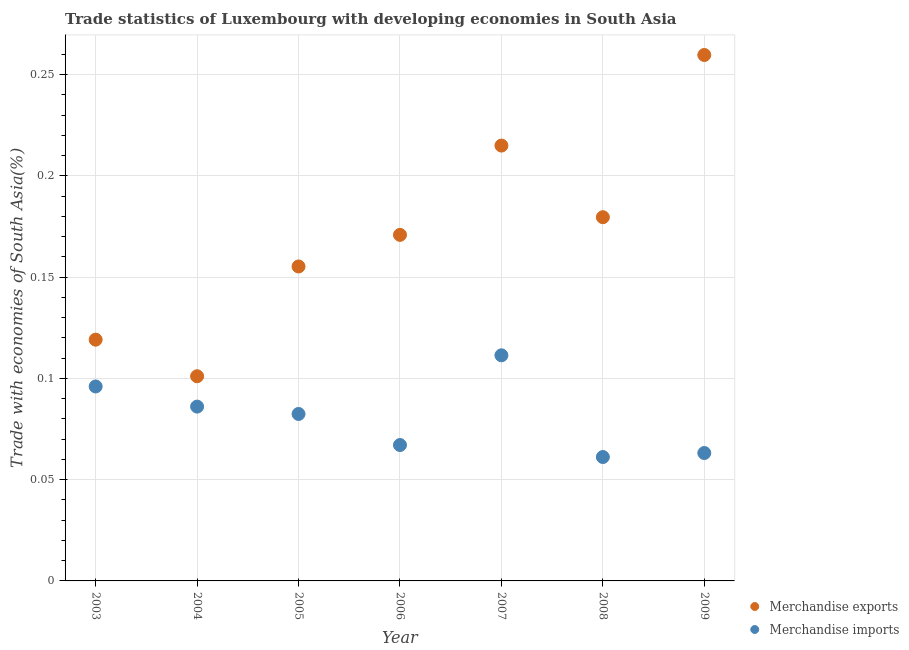How many different coloured dotlines are there?
Offer a terse response. 2. Is the number of dotlines equal to the number of legend labels?
Your response must be concise. Yes. What is the merchandise exports in 2007?
Ensure brevity in your answer.  0.21. Across all years, what is the maximum merchandise exports?
Ensure brevity in your answer.  0.26. Across all years, what is the minimum merchandise exports?
Your answer should be compact. 0.1. In which year was the merchandise exports minimum?
Keep it short and to the point. 2004. What is the total merchandise imports in the graph?
Your answer should be very brief. 0.57. What is the difference between the merchandise imports in 2007 and that in 2008?
Give a very brief answer. 0.05. What is the difference between the merchandise exports in 2003 and the merchandise imports in 2008?
Provide a succinct answer. 0.06. What is the average merchandise imports per year?
Your answer should be compact. 0.08. In the year 2004, what is the difference between the merchandise imports and merchandise exports?
Provide a short and direct response. -0.01. In how many years, is the merchandise exports greater than 0.22 %?
Your answer should be very brief. 1. What is the ratio of the merchandise imports in 2005 to that in 2009?
Offer a very short reply. 1.31. Is the merchandise exports in 2004 less than that in 2005?
Offer a very short reply. Yes. Is the difference between the merchandise exports in 2005 and 2006 greater than the difference between the merchandise imports in 2005 and 2006?
Give a very brief answer. No. What is the difference between the highest and the second highest merchandise imports?
Give a very brief answer. 0.02. What is the difference between the highest and the lowest merchandise imports?
Make the answer very short. 0.05. Is the sum of the merchandise exports in 2003 and 2006 greater than the maximum merchandise imports across all years?
Provide a short and direct response. Yes. How many years are there in the graph?
Offer a very short reply. 7. Are the values on the major ticks of Y-axis written in scientific E-notation?
Offer a terse response. No. Where does the legend appear in the graph?
Ensure brevity in your answer.  Bottom right. How are the legend labels stacked?
Your answer should be compact. Vertical. What is the title of the graph?
Make the answer very short. Trade statistics of Luxembourg with developing economies in South Asia. Does "Female" appear as one of the legend labels in the graph?
Offer a terse response. No. What is the label or title of the X-axis?
Provide a succinct answer. Year. What is the label or title of the Y-axis?
Ensure brevity in your answer.  Trade with economies of South Asia(%). What is the Trade with economies of South Asia(%) in Merchandise exports in 2003?
Offer a terse response. 0.12. What is the Trade with economies of South Asia(%) in Merchandise imports in 2003?
Your answer should be compact. 0.1. What is the Trade with economies of South Asia(%) in Merchandise exports in 2004?
Keep it short and to the point. 0.1. What is the Trade with economies of South Asia(%) of Merchandise imports in 2004?
Your answer should be compact. 0.09. What is the Trade with economies of South Asia(%) in Merchandise exports in 2005?
Offer a very short reply. 0.16. What is the Trade with economies of South Asia(%) in Merchandise imports in 2005?
Ensure brevity in your answer.  0.08. What is the Trade with economies of South Asia(%) of Merchandise exports in 2006?
Your answer should be very brief. 0.17. What is the Trade with economies of South Asia(%) of Merchandise imports in 2006?
Offer a very short reply. 0.07. What is the Trade with economies of South Asia(%) of Merchandise exports in 2007?
Provide a short and direct response. 0.21. What is the Trade with economies of South Asia(%) of Merchandise imports in 2007?
Provide a short and direct response. 0.11. What is the Trade with economies of South Asia(%) in Merchandise exports in 2008?
Your answer should be very brief. 0.18. What is the Trade with economies of South Asia(%) in Merchandise imports in 2008?
Provide a succinct answer. 0.06. What is the Trade with economies of South Asia(%) of Merchandise exports in 2009?
Ensure brevity in your answer.  0.26. What is the Trade with economies of South Asia(%) in Merchandise imports in 2009?
Ensure brevity in your answer.  0.06. Across all years, what is the maximum Trade with economies of South Asia(%) of Merchandise exports?
Give a very brief answer. 0.26. Across all years, what is the maximum Trade with economies of South Asia(%) of Merchandise imports?
Your answer should be compact. 0.11. Across all years, what is the minimum Trade with economies of South Asia(%) in Merchandise exports?
Offer a very short reply. 0.1. Across all years, what is the minimum Trade with economies of South Asia(%) in Merchandise imports?
Your response must be concise. 0.06. What is the total Trade with economies of South Asia(%) in Merchandise exports in the graph?
Your answer should be very brief. 1.2. What is the total Trade with economies of South Asia(%) of Merchandise imports in the graph?
Make the answer very short. 0.57. What is the difference between the Trade with economies of South Asia(%) in Merchandise exports in 2003 and that in 2004?
Your answer should be compact. 0.02. What is the difference between the Trade with economies of South Asia(%) of Merchandise imports in 2003 and that in 2004?
Your response must be concise. 0.01. What is the difference between the Trade with economies of South Asia(%) of Merchandise exports in 2003 and that in 2005?
Offer a terse response. -0.04. What is the difference between the Trade with economies of South Asia(%) in Merchandise imports in 2003 and that in 2005?
Offer a very short reply. 0.01. What is the difference between the Trade with economies of South Asia(%) in Merchandise exports in 2003 and that in 2006?
Your answer should be compact. -0.05. What is the difference between the Trade with economies of South Asia(%) of Merchandise imports in 2003 and that in 2006?
Your answer should be very brief. 0.03. What is the difference between the Trade with economies of South Asia(%) in Merchandise exports in 2003 and that in 2007?
Keep it short and to the point. -0.1. What is the difference between the Trade with economies of South Asia(%) of Merchandise imports in 2003 and that in 2007?
Provide a succinct answer. -0.02. What is the difference between the Trade with economies of South Asia(%) of Merchandise exports in 2003 and that in 2008?
Your answer should be compact. -0.06. What is the difference between the Trade with economies of South Asia(%) in Merchandise imports in 2003 and that in 2008?
Give a very brief answer. 0.03. What is the difference between the Trade with economies of South Asia(%) of Merchandise exports in 2003 and that in 2009?
Offer a very short reply. -0.14. What is the difference between the Trade with economies of South Asia(%) in Merchandise imports in 2003 and that in 2009?
Your answer should be compact. 0.03. What is the difference between the Trade with economies of South Asia(%) of Merchandise exports in 2004 and that in 2005?
Your answer should be very brief. -0.05. What is the difference between the Trade with economies of South Asia(%) of Merchandise imports in 2004 and that in 2005?
Your answer should be compact. 0. What is the difference between the Trade with economies of South Asia(%) in Merchandise exports in 2004 and that in 2006?
Keep it short and to the point. -0.07. What is the difference between the Trade with economies of South Asia(%) of Merchandise imports in 2004 and that in 2006?
Keep it short and to the point. 0.02. What is the difference between the Trade with economies of South Asia(%) of Merchandise exports in 2004 and that in 2007?
Keep it short and to the point. -0.11. What is the difference between the Trade with economies of South Asia(%) of Merchandise imports in 2004 and that in 2007?
Provide a succinct answer. -0.03. What is the difference between the Trade with economies of South Asia(%) in Merchandise exports in 2004 and that in 2008?
Offer a terse response. -0.08. What is the difference between the Trade with economies of South Asia(%) in Merchandise imports in 2004 and that in 2008?
Ensure brevity in your answer.  0.02. What is the difference between the Trade with economies of South Asia(%) of Merchandise exports in 2004 and that in 2009?
Provide a short and direct response. -0.16. What is the difference between the Trade with economies of South Asia(%) in Merchandise imports in 2004 and that in 2009?
Provide a short and direct response. 0.02. What is the difference between the Trade with economies of South Asia(%) in Merchandise exports in 2005 and that in 2006?
Your response must be concise. -0.02. What is the difference between the Trade with economies of South Asia(%) of Merchandise imports in 2005 and that in 2006?
Give a very brief answer. 0.02. What is the difference between the Trade with economies of South Asia(%) in Merchandise exports in 2005 and that in 2007?
Make the answer very short. -0.06. What is the difference between the Trade with economies of South Asia(%) of Merchandise imports in 2005 and that in 2007?
Offer a terse response. -0.03. What is the difference between the Trade with economies of South Asia(%) in Merchandise exports in 2005 and that in 2008?
Offer a terse response. -0.02. What is the difference between the Trade with economies of South Asia(%) in Merchandise imports in 2005 and that in 2008?
Give a very brief answer. 0.02. What is the difference between the Trade with economies of South Asia(%) of Merchandise exports in 2005 and that in 2009?
Make the answer very short. -0.1. What is the difference between the Trade with economies of South Asia(%) of Merchandise imports in 2005 and that in 2009?
Provide a short and direct response. 0.02. What is the difference between the Trade with economies of South Asia(%) in Merchandise exports in 2006 and that in 2007?
Provide a short and direct response. -0.04. What is the difference between the Trade with economies of South Asia(%) of Merchandise imports in 2006 and that in 2007?
Offer a terse response. -0.04. What is the difference between the Trade with economies of South Asia(%) in Merchandise exports in 2006 and that in 2008?
Give a very brief answer. -0.01. What is the difference between the Trade with economies of South Asia(%) of Merchandise imports in 2006 and that in 2008?
Make the answer very short. 0.01. What is the difference between the Trade with economies of South Asia(%) in Merchandise exports in 2006 and that in 2009?
Your answer should be very brief. -0.09. What is the difference between the Trade with economies of South Asia(%) of Merchandise imports in 2006 and that in 2009?
Keep it short and to the point. 0. What is the difference between the Trade with economies of South Asia(%) of Merchandise exports in 2007 and that in 2008?
Ensure brevity in your answer.  0.04. What is the difference between the Trade with economies of South Asia(%) of Merchandise imports in 2007 and that in 2008?
Ensure brevity in your answer.  0.05. What is the difference between the Trade with economies of South Asia(%) of Merchandise exports in 2007 and that in 2009?
Make the answer very short. -0.04. What is the difference between the Trade with economies of South Asia(%) in Merchandise imports in 2007 and that in 2009?
Offer a very short reply. 0.05. What is the difference between the Trade with economies of South Asia(%) in Merchandise exports in 2008 and that in 2009?
Keep it short and to the point. -0.08. What is the difference between the Trade with economies of South Asia(%) in Merchandise imports in 2008 and that in 2009?
Offer a terse response. -0. What is the difference between the Trade with economies of South Asia(%) of Merchandise exports in 2003 and the Trade with economies of South Asia(%) of Merchandise imports in 2004?
Offer a terse response. 0.03. What is the difference between the Trade with economies of South Asia(%) in Merchandise exports in 2003 and the Trade with economies of South Asia(%) in Merchandise imports in 2005?
Your response must be concise. 0.04. What is the difference between the Trade with economies of South Asia(%) in Merchandise exports in 2003 and the Trade with economies of South Asia(%) in Merchandise imports in 2006?
Your answer should be very brief. 0.05. What is the difference between the Trade with economies of South Asia(%) in Merchandise exports in 2003 and the Trade with economies of South Asia(%) in Merchandise imports in 2007?
Provide a short and direct response. 0.01. What is the difference between the Trade with economies of South Asia(%) in Merchandise exports in 2003 and the Trade with economies of South Asia(%) in Merchandise imports in 2008?
Provide a short and direct response. 0.06. What is the difference between the Trade with economies of South Asia(%) of Merchandise exports in 2003 and the Trade with economies of South Asia(%) of Merchandise imports in 2009?
Make the answer very short. 0.06. What is the difference between the Trade with economies of South Asia(%) of Merchandise exports in 2004 and the Trade with economies of South Asia(%) of Merchandise imports in 2005?
Provide a succinct answer. 0.02. What is the difference between the Trade with economies of South Asia(%) in Merchandise exports in 2004 and the Trade with economies of South Asia(%) in Merchandise imports in 2006?
Your response must be concise. 0.03. What is the difference between the Trade with economies of South Asia(%) in Merchandise exports in 2004 and the Trade with economies of South Asia(%) in Merchandise imports in 2007?
Make the answer very short. -0.01. What is the difference between the Trade with economies of South Asia(%) of Merchandise exports in 2004 and the Trade with economies of South Asia(%) of Merchandise imports in 2008?
Offer a very short reply. 0.04. What is the difference between the Trade with economies of South Asia(%) of Merchandise exports in 2004 and the Trade with economies of South Asia(%) of Merchandise imports in 2009?
Your answer should be very brief. 0.04. What is the difference between the Trade with economies of South Asia(%) of Merchandise exports in 2005 and the Trade with economies of South Asia(%) of Merchandise imports in 2006?
Your answer should be very brief. 0.09. What is the difference between the Trade with economies of South Asia(%) in Merchandise exports in 2005 and the Trade with economies of South Asia(%) in Merchandise imports in 2007?
Your answer should be very brief. 0.04. What is the difference between the Trade with economies of South Asia(%) of Merchandise exports in 2005 and the Trade with economies of South Asia(%) of Merchandise imports in 2008?
Provide a succinct answer. 0.09. What is the difference between the Trade with economies of South Asia(%) of Merchandise exports in 2005 and the Trade with economies of South Asia(%) of Merchandise imports in 2009?
Keep it short and to the point. 0.09. What is the difference between the Trade with economies of South Asia(%) in Merchandise exports in 2006 and the Trade with economies of South Asia(%) in Merchandise imports in 2007?
Your answer should be compact. 0.06. What is the difference between the Trade with economies of South Asia(%) of Merchandise exports in 2006 and the Trade with economies of South Asia(%) of Merchandise imports in 2008?
Offer a very short reply. 0.11. What is the difference between the Trade with economies of South Asia(%) of Merchandise exports in 2006 and the Trade with economies of South Asia(%) of Merchandise imports in 2009?
Make the answer very short. 0.11. What is the difference between the Trade with economies of South Asia(%) in Merchandise exports in 2007 and the Trade with economies of South Asia(%) in Merchandise imports in 2008?
Ensure brevity in your answer.  0.15. What is the difference between the Trade with economies of South Asia(%) of Merchandise exports in 2007 and the Trade with economies of South Asia(%) of Merchandise imports in 2009?
Offer a very short reply. 0.15. What is the difference between the Trade with economies of South Asia(%) of Merchandise exports in 2008 and the Trade with economies of South Asia(%) of Merchandise imports in 2009?
Keep it short and to the point. 0.12. What is the average Trade with economies of South Asia(%) of Merchandise exports per year?
Offer a terse response. 0.17. What is the average Trade with economies of South Asia(%) of Merchandise imports per year?
Provide a succinct answer. 0.08. In the year 2003, what is the difference between the Trade with economies of South Asia(%) in Merchandise exports and Trade with economies of South Asia(%) in Merchandise imports?
Offer a terse response. 0.02. In the year 2004, what is the difference between the Trade with economies of South Asia(%) in Merchandise exports and Trade with economies of South Asia(%) in Merchandise imports?
Provide a succinct answer. 0.01. In the year 2005, what is the difference between the Trade with economies of South Asia(%) in Merchandise exports and Trade with economies of South Asia(%) in Merchandise imports?
Keep it short and to the point. 0.07. In the year 2006, what is the difference between the Trade with economies of South Asia(%) in Merchandise exports and Trade with economies of South Asia(%) in Merchandise imports?
Offer a terse response. 0.1. In the year 2007, what is the difference between the Trade with economies of South Asia(%) in Merchandise exports and Trade with economies of South Asia(%) in Merchandise imports?
Offer a very short reply. 0.1. In the year 2008, what is the difference between the Trade with economies of South Asia(%) in Merchandise exports and Trade with economies of South Asia(%) in Merchandise imports?
Offer a terse response. 0.12. In the year 2009, what is the difference between the Trade with economies of South Asia(%) in Merchandise exports and Trade with economies of South Asia(%) in Merchandise imports?
Give a very brief answer. 0.2. What is the ratio of the Trade with economies of South Asia(%) in Merchandise exports in 2003 to that in 2004?
Keep it short and to the point. 1.18. What is the ratio of the Trade with economies of South Asia(%) of Merchandise imports in 2003 to that in 2004?
Give a very brief answer. 1.12. What is the ratio of the Trade with economies of South Asia(%) of Merchandise exports in 2003 to that in 2005?
Your answer should be very brief. 0.77. What is the ratio of the Trade with economies of South Asia(%) of Merchandise imports in 2003 to that in 2005?
Your response must be concise. 1.16. What is the ratio of the Trade with economies of South Asia(%) in Merchandise exports in 2003 to that in 2006?
Your answer should be compact. 0.7. What is the ratio of the Trade with economies of South Asia(%) in Merchandise imports in 2003 to that in 2006?
Offer a very short reply. 1.43. What is the ratio of the Trade with economies of South Asia(%) of Merchandise exports in 2003 to that in 2007?
Provide a succinct answer. 0.55. What is the ratio of the Trade with economies of South Asia(%) of Merchandise imports in 2003 to that in 2007?
Offer a terse response. 0.86. What is the ratio of the Trade with economies of South Asia(%) of Merchandise exports in 2003 to that in 2008?
Provide a succinct answer. 0.66. What is the ratio of the Trade with economies of South Asia(%) in Merchandise imports in 2003 to that in 2008?
Ensure brevity in your answer.  1.57. What is the ratio of the Trade with economies of South Asia(%) in Merchandise exports in 2003 to that in 2009?
Your answer should be compact. 0.46. What is the ratio of the Trade with economies of South Asia(%) in Merchandise imports in 2003 to that in 2009?
Provide a succinct answer. 1.52. What is the ratio of the Trade with economies of South Asia(%) of Merchandise exports in 2004 to that in 2005?
Ensure brevity in your answer.  0.65. What is the ratio of the Trade with economies of South Asia(%) in Merchandise imports in 2004 to that in 2005?
Provide a succinct answer. 1.04. What is the ratio of the Trade with economies of South Asia(%) of Merchandise exports in 2004 to that in 2006?
Offer a very short reply. 0.59. What is the ratio of the Trade with economies of South Asia(%) of Merchandise imports in 2004 to that in 2006?
Provide a short and direct response. 1.28. What is the ratio of the Trade with economies of South Asia(%) in Merchandise exports in 2004 to that in 2007?
Keep it short and to the point. 0.47. What is the ratio of the Trade with economies of South Asia(%) in Merchandise imports in 2004 to that in 2007?
Make the answer very short. 0.77. What is the ratio of the Trade with economies of South Asia(%) of Merchandise exports in 2004 to that in 2008?
Ensure brevity in your answer.  0.56. What is the ratio of the Trade with economies of South Asia(%) in Merchandise imports in 2004 to that in 2008?
Offer a terse response. 1.41. What is the ratio of the Trade with economies of South Asia(%) of Merchandise exports in 2004 to that in 2009?
Your answer should be compact. 0.39. What is the ratio of the Trade with economies of South Asia(%) in Merchandise imports in 2004 to that in 2009?
Keep it short and to the point. 1.36. What is the ratio of the Trade with economies of South Asia(%) in Merchandise exports in 2005 to that in 2006?
Ensure brevity in your answer.  0.91. What is the ratio of the Trade with economies of South Asia(%) in Merchandise imports in 2005 to that in 2006?
Your response must be concise. 1.23. What is the ratio of the Trade with economies of South Asia(%) in Merchandise exports in 2005 to that in 2007?
Keep it short and to the point. 0.72. What is the ratio of the Trade with economies of South Asia(%) of Merchandise imports in 2005 to that in 2007?
Your answer should be very brief. 0.74. What is the ratio of the Trade with economies of South Asia(%) of Merchandise exports in 2005 to that in 2008?
Make the answer very short. 0.86. What is the ratio of the Trade with economies of South Asia(%) in Merchandise imports in 2005 to that in 2008?
Provide a short and direct response. 1.35. What is the ratio of the Trade with economies of South Asia(%) in Merchandise exports in 2005 to that in 2009?
Your answer should be very brief. 0.6. What is the ratio of the Trade with economies of South Asia(%) in Merchandise imports in 2005 to that in 2009?
Keep it short and to the point. 1.31. What is the ratio of the Trade with economies of South Asia(%) of Merchandise exports in 2006 to that in 2007?
Your response must be concise. 0.79. What is the ratio of the Trade with economies of South Asia(%) in Merchandise imports in 2006 to that in 2007?
Ensure brevity in your answer.  0.6. What is the ratio of the Trade with economies of South Asia(%) of Merchandise exports in 2006 to that in 2008?
Offer a terse response. 0.95. What is the ratio of the Trade with economies of South Asia(%) of Merchandise imports in 2006 to that in 2008?
Make the answer very short. 1.1. What is the ratio of the Trade with economies of South Asia(%) of Merchandise exports in 2006 to that in 2009?
Provide a succinct answer. 0.66. What is the ratio of the Trade with economies of South Asia(%) in Merchandise imports in 2006 to that in 2009?
Provide a short and direct response. 1.06. What is the ratio of the Trade with economies of South Asia(%) of Merchandise exports in 2007 to that in 2008?
Offer a terse response. 1.2. What is the ratio of the Trade with economies of South Asia(%) in Merchandise imports in 2007 to that in 2008?
Keep it short and to the point. 1.82. What is the ratio of the Trade with economies of South Asia(%) of Merchandise exports in 2007 to that in 2009?
Make the answer very short. 0.83. What is the ratio of the Trade with economies of South Asia(%) in Merchandise imports in 2007 to that in 2009?
Your response must be concise. 1.76. What is the ratio of the Trade with economies of South Asia(%) in Merchandise exports in 2008 to that in 2009?
Provide a short and direct response. 0.69. What is the ratio of the Trade with economies of South Asia(%) of Merchandise imports in 2008 to that in 2009?
Offer a very short reply. 0.97. What is the difference between the highest and the second highest Trade with economies of South Asia(%) of Merchandise exports?
Give a very brief answer. 0.04. What is the difference between the highest and the second highest Trade with economies of South Asia(%) of Merchandise imports?
Your response must be concise. 0.02. What is the difference between the highest and the lowest Trade with economies of South Asia(%) of Merchandise exports?
Provide a short and direct response. 0.16. What is the difference between the highest and the lowest Trade with economies of South Asia(%) of Merchandise imports?
Provide a succinct answer. 0.05. 